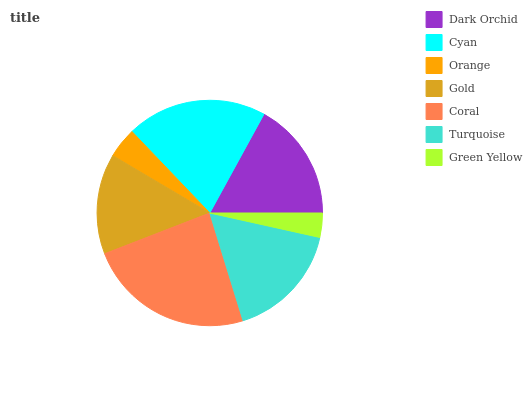Is Green Yellow the minimum?
Answer yes or no. Yes. Is Coral the maximum?
Answer yes or no. Yes. Is Cyan the minimum?
Answer yes or no. No. Is Cyan the maximum?
Answer yes or no. No. Is Cyan greater than Dark Orchid?
Answer yes or no. Yes. Is Dark Orchid less than Cyan?
Answer yes or no. Yes. Is Dark Orchid greater than Cyan?
Answer yes or no. No. Is Cyan less than Dark Orchid?
Answer yes or no. No. Is Turquoise the high median?
Answer yes or no. Yes. Is Turquoise the low median?
Answer yes or no. Yes. Is Green Yellow the high median?
Answer yes or no. No. Is Gold the low median?
Answer yes or no. No. 